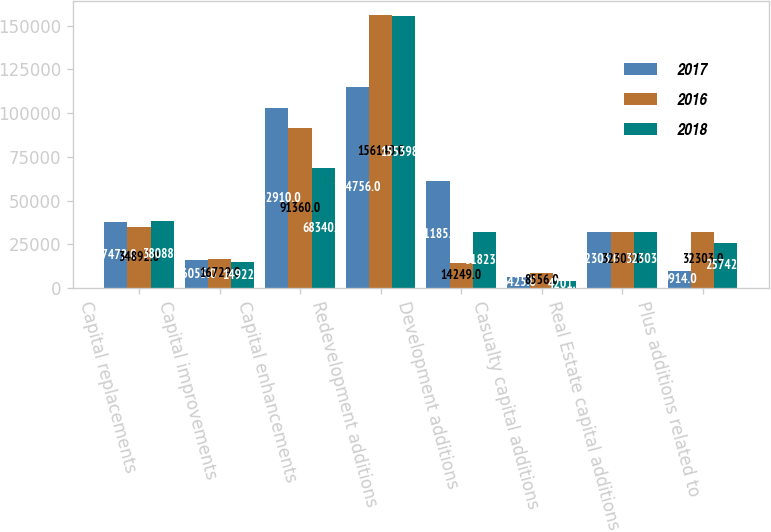Convert chart to OTSL. <chart><loc_0><loc_0><loc_500><loc_500><stacked_bar_chart><ecel><fcel>Capital replacements<fcel>Capital improvements<fcel>Capital enhancements<fcel>Redevelopment additions<fcel>Development additions<fcel>Casualty capital additions<fcel>Real Estate capital additions<fcel>Plus additions related to<nl><fcel>2017<fcel>37472<fcel>16055<fcel>102910<fcel>114756<fcel>61185<fcel>6425<fcel>32303<fcel>9914<nl><fcel>2016<fcel>34892<fcel>16729<fcel>91360<fcel>156140<fcel>14249<fcel>8556<fcel>32303<fcel>32303<nl><fcel>2018<fcel>38088<fcel>14922<fcel>68340<fcel>155398<fcel>31823<fcel>4201<fcel>32303<fcel>25742<nl></chart> 